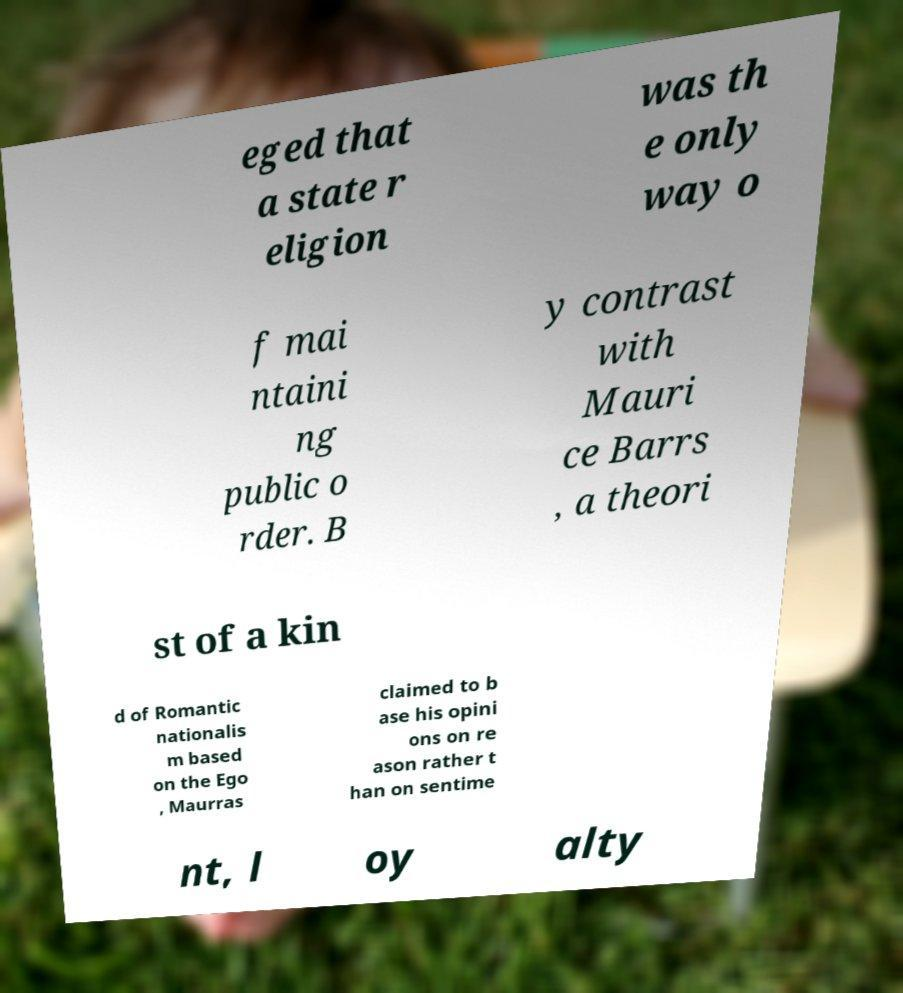Can you read and provide the text displayed in the image?This photo seems to have some interesting text. Can you extract and type it out for me? eged that a state r eligion was th e only way o f mai ntaini ng public o rder. B y contrast with Mauri ce Barrs , a theori st of a kin d of Romantic nationalis m based on the Ego , Maurras claimed to b ase his opini ons on re ason rather t han on sentime nt, l oy alty 